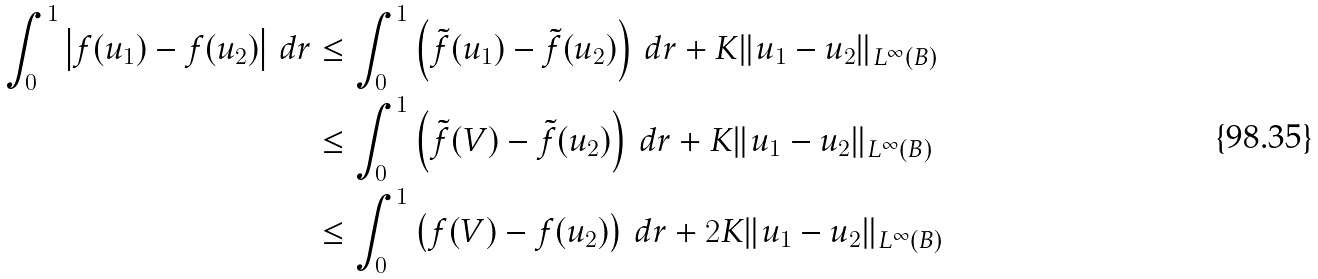<formula> <loc_0><loc_0><loc_500><loc_500>\int _ { 0 } ^ { 1 } \left | f ( u _ { 1 } ) - f ( u _ { 2 } ) \right | \, d r & \leq \int _ { 0 } ^ { 1 } \left ( \tilde { f } ( u _ { 1 } ) - \tilde { f } ( u _ { 2 } ) \right ) \, d r + K \| u _ { 1 } - u _ { 2 } \| _ { L ^ { \infty } ( B ) } \\ & \leq \int _ { 0 } ^ { 1 } \left ( \tilde { f } ( V ) - \tilde { f } ( u _ { 2 } ) \right ) \, d r + K \| u _ { 1 } - u _ { 2 } \| _ { L ^ { \infty } ( B ) } \\ & \leq \int _ { 0 } ^ { 1 } \left ( f ( V ) - f ( u _ { 2 } ) \right ) \, d r + 2 K \| u _ { 1 } - u _ { 2 } \| _ { L ^ { \infty } ( B ) }</formula> 